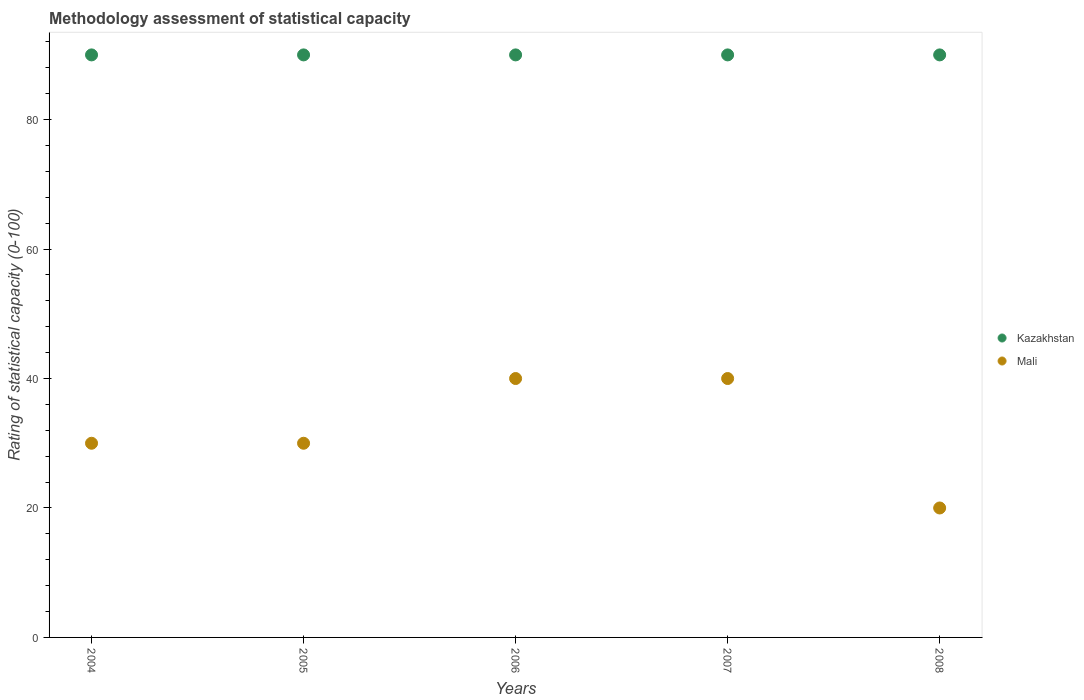Is the number of dotlines equal to the number of legend labels?
Ensure brevity in your answer.  Yes. What is the rating of statistical capacity in Mali in 2006?
Offer a very short reply. 40. Across all years, what is the maximum rating of statistical capacity in Mali?
Provide a short and direct response. 40. Across all years, what is the minimum rating of statistical capacity in Kazakhstan?
Provide a short and direct response. 90. In which year was the rating of statistical capacity in Kazakhstan minimum?
Give a very brief answer. 2004. What is the total rating of statistical capacity in Kazakhstan in the graph?
Keep it short and to the point. 450. What is the difference between the rating of statistical capacity in Kazakhstan in 2006 and that in 2008?
Provide a succinct answer. 0. What is the difference between the rating of statistical capacity in Kazakhstan in 2004 and the rating of statistical capacity in Mali in 2005?
Offer a terse response. 60. In the year 2005, what is the difference between the rating of statistical capacity in Mali and rating of statistical capacity in Kazakhstan?
Your answer should be very brief. -60. Is the rating of statistical capacity in Kazakhstan in 2006 less than that in 2007?
Your response must be concise. No. Is the difference between the rating of statistical capacity in Mali in 2006 and 2007 greater than the difference between the rating of statistical capacity in Kazakhstan in 2006 and 2007?
Provide a short and direct response. No. What is the difference between the highest and the lowest rating of statistical capacity in Kazakhstan?
Ensure brevity in your answer.  0. In how many years, is the rating of statistical capacity in Kazakhstan greater than the average rating of statistical capacity in Kazakhstan taken over all years?
Offer a very short reply. 0. Does the rating of statistical capacity in Mali monotonically increase over the years?
Provide a succinct answer. No. Is the rating of statistical capacity in Mali strictly greater than the rating of statistical capacity in Kazakhstan over the years?
Your answer should be compact. No. How many dotlines are there?
Offer a terse response. 2. How many years are there in the graph?
Your answer should be compact. 5. What is the difference between two consecutive major ticks on the Y-axis?
Keep it short and to the point. 20. Are the values on the major ticks of Y-axis written in scientific E-notation?
Your answer should be very brief. No. Does the graph contain any zero values?
Offer a very short reply. No. What is the title of the graph?
Your response must be concise. Methodology assessment of statistical capacity. What is the label or title of the Y-axis?
Offer a terse response. Rating of statistical capacity (0-100). What is the Rating of statistical capacity (0-100) in Kazakhstan in 2004?
Provide a short and direct response. 90. What is the Rating of statistical capacity (0-100) in Kazakhstan in 2006?
Give a very brief answer. 90. What is the Rating of statistical capacity (0-100) of Mali in 2006?
Your answer should be compact. 40. What is the Rating of statistical capacity (0-100) in Kazakhstan in 2008?
Ensure brevity in your answer.  90. What is the Rating of statistical capacity (0-100) in Mali in 2008?
Keep it short and to the point. 20. Across all years, what is the maximum Rating of statistical capacity (0-100) of Mali?
Provide a succinct answer. 40. Across all years, what is the minimum Rating of statistical capacity (0-100) of Mali?
Your answer should be very brief. 20. What is the total Rating of statistical capacity (0-100) in Kazakhstan in the graph?
Provide a succinct answer. 450. What is the total Rating of statistical capacity (0-100) in Mali in the graph?
Your answer should be very brief. 160. What is the difference between the Rating of statistical capacity (0-100) in Mali in 2004 and that in 2006?
Your answer should be compact. -10. What is the difference between the Rating of statistical capacity (0-100) in Kazakhstan in 2004 and that in 2008?
Provide a succinct answer. 0. What is the difference between the Rating of statistical capacity (0-100) of Mali in 2004 and that in 2008?
Provide a short and direct response. 10. What is the difference between the Rating of statistical capacity (0-100) of Kazakhstan in 2005 and that in 2006?
Provide a short and direct response. 0. What is the difference between the Rating of statistical capacity (0-100) in Kazakhstan in 2005 and that in 2007?
Make the answer very short. 0. What is the difference between the Rating of statistical capacity (0-100) of Mali in 2005 and that in 2008?
Offer a very short reply. 10. What is the difference between the Rating of statistical capacity (0-100) of Mali in 2006 and that in 2007?
Your answer should be very brief. 0. What is the difference between the Rating of statistical capacity (0-100) in Kazakhstan in 2007 and that in 2008?
Keep it short and to the point. 0. What is the difference between the Rating of statistical capacity (0-100) of Mali in 2007 and that in 2008?
Your answer should be very brief. 20. What is the difference between the Rating of statistical capacity (0-100) of Kazakhstan in 2004 and the Rating of statistical capacity (0-100) of Mali in 2005?
Keep it short and to the point. 60. What is the difference between the Rating of statistical capacity (0-100) of Kazakhstan in 2004 and the Rating of statistical capacity (0-100) of Mali in 2008?
Provide a short and direct response. 70. What is the difference between the Rating of statistical capacity (0-100) of Kazakhstan in 2005 and the Rating of statistical capacity (0-100) of Mali in 2007?
Your response must be concise. 50. What is the difference between the Rating of statistical capacity (0-100) of Kazakhstan in 2005 and the Rating of statistical capacity (0-100) of Mali in 2008?
Your answer should be compact. 70. What is the difference between the Rating of statistical capacity (0-100) in Kazakhstan in 2006 and the Rating of statistical capacity (0-100) in Mali in 2007?
Provide a succinct answer. 50. What is the difference between the Rating of statistical capacity (0-100) of Kazakhstan in 2006 and the Rating of statistical capacity (0-100) of Mali in 2008?
Keep it short and to the point. 70. What is the average Rating of statistical capacity (0-100) of Kazakhstan per year?
Your answer should be compact. 90. What is the average Rating of statistical capacity (0-100) of Mali per year?
Provide a short and direct response. 32. In the year 2004, what is the difference between the Rating of statistical capacity (0-100) in Kazakhstan and Rating of statistical capacity (0-100) in Mali?
Your answer should be compact. 60. In the year 2005, what is the difference between the Rating of statistical capacity (0-100) of Kazakhstan and Rating of statistical capacity (0-100) of Mali?
Your response must be concise. 60. In the year 2007, what is the difference between the Rating of statistical capacity (0-100) of Kazakhstan and Rating of statistical capacity (0-100) of Mali?
Your answer should be very brief. 50. In the year 2008, what is the difference between the Rating of statistical capacity (0-100) in Kazakhstan and Rating of statistical capacity (0-100) in Mali?
Provide a succinct answer. 70. What is the ratio of the Rating of statistical capacity (0-100) of Kazakhstan in 2004 to that in 2005?
Offer a very short reply. 1. What is the ratio of the Rating of statistical capacity (0-100) in Mali in 2004 to that in 2005?
Provide a short and direct response. 1. What is the ratio of the Rating of statistical capacity (0-100) in Kazakhstan in 2004 to that in 2006?
Offer a terse response. 1. What is the ratio of the Rating of statistical capacity (0-100) of Mali in 2004 to that in 2006?
Your answer should be compact. 0.75. What is the ratio of the Rating of statistical capacity (0-100) in Kazakhstan in 2004 to that in 2007?
Offer a very short reply. 1. What is the ratio of the Rating of statistical capacity (0-100) in Kazakhstan in 2004 to that in 2008?
Give a very brief answer. 1. What is the ratio of the Rating of statistical capacity (0-100) in Mali in 2004 to that in 2008?
Keep it short and to the point. 1.5. What is the ratio of the Rating of statistical capacity (0-100) of Kazakhstan in 2005 to that in 2007?
Give a very brief answer. 1. What is the ratio of the Rating of statistical capacity (0-100) in Mali in 2005 to that in 2008?
Your answer should be very brief. 1.5. What is the ratio of the Rating of statistical capacity (0-100) in Kazakhstan in 2006 to that in 2008?
Give a very brief answer. 1. What is the difference between the highest and the second highest Rating of statistical capacity (0-100) of Mali?
Your answer should be compact. 0. What is the difference between the highest and the lowest Rating of statistical capacity (0-100) of Mali?
Provide a short and direct response. 20. 